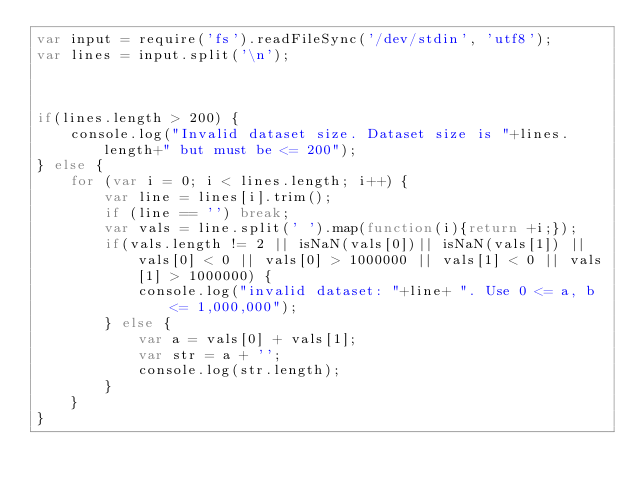<code> <loc_0><loc_0><loc_500><loc_500><_JavaScript_>var input = require('fs').readFileSync('/dev/stdin', 'utf8');
var lines = input.split('\n');



if(lines.length > 200) {
	console.log("Invalid dataset size. Dataset size is "+lines.length+" but must be <= 200");
} else {
	for (var i = 0; i < lines.length; i++) {
		var line = lines[i].trim();
	    if (line == '') break;
	    var vals = line.split(' ').map(function(i){return +i;});
	    if(vals.length != 2 || isNaN(vals[0])|| isNaN(vals[1]) || vals[0] < 0 || vals[0] > 1000000 || vals[1] < 0 || vals[1] > 1000000) {
	    	console.log("invalid dataset: "+line+ ". Use 0 <= a, b <= 1,000,000");
	    } else {
	    	var a = vals[0] + vals[1];
	    	var str = a + '';
	    	console.log(str.length);
		}
	}
}</code> 